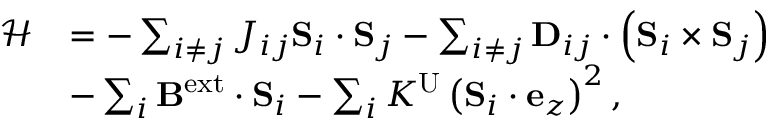Convert formula to latex. <formula><loc_0><loc_0><loc_500><loc_500>\begin{array} { r l } { \ m a t h s c r { H } } & { = - \sum _ { i \neq j } J _ { i j } S _ { i } \cdot S _ { j } - \sum _ { i \neq j } D _ { i j } \cdot \left ( S _ { i } \times S _ { j } \right ) } \\ & { - \sum _ { i } B ^ { e x t } \cdot S _ { i } - \sum _ { i } K ^ { U } \left ( S _ { i } \cdot e _ { z } \right ) ^ { 2 } , } \end{array}</formula> 